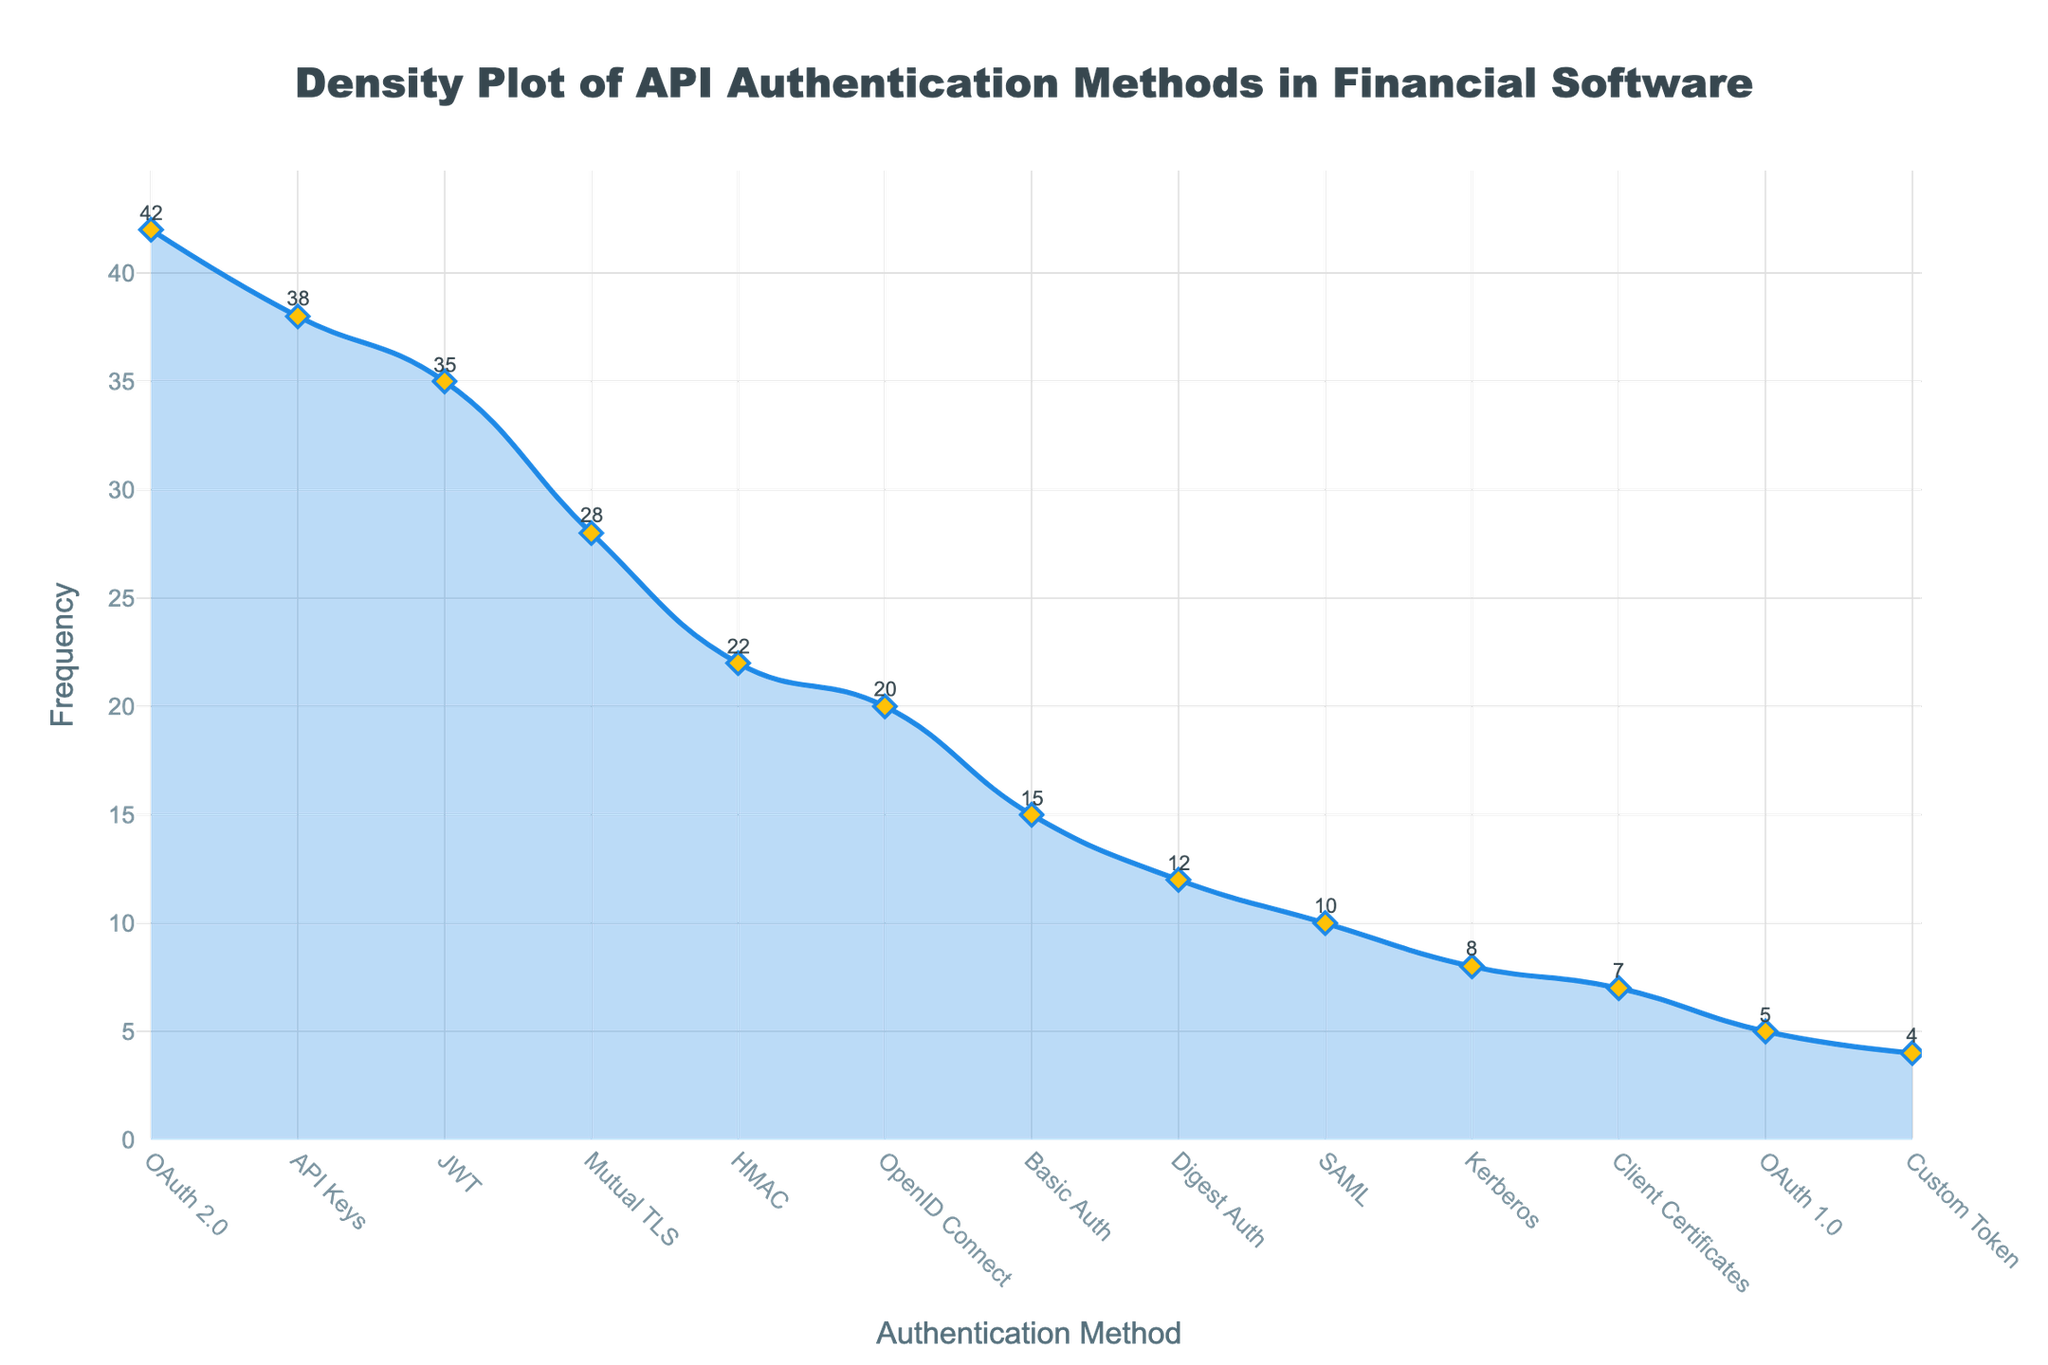What's the title of the plot? The title is displayed at the top of the plot and is formatted in a large, bold text.
Answer: Density Plot of API Authentication Methods in Financial Software Which authentication method has the highest frequency? By looking at the peak of the density plot and the corresponding label on the x-axis, one can see the highest peak corresponds to OAuth 2.0.
Answer: OAuth 2.0 How many authentication methods have a frequency greater than 30? We need to count the number of peaks in the plot that rise above the 30 mark on the y-axis. These correspond to OAuth 2.0, API Keys, and JWT.
Answer: 3 What is the approximate frequency difference between the highest and lowest reported methods? Identify the frequencies of the highest (OAuth 2.0 with 42) and lowest (Custom Token with 4) methods and subtract the latter from the former.
Answer: 38 Which two authentication methods have the closest frequencies, and what are their values? Compare frequency values closer to each other visually. Mutual TLS (28) and HMAC (22) have the closest frequencies with a difference of 6.
Answer: Mutual TLS and HMAC, with frequencies 28 and 22 What can you say about the trend of frequencies regarding API Key usage compared to JWT usage? The trend line for API Keys is slightly higher but close to the JWT trend line, which suggests that both methods have a similar level of use but API Keys are slightly more frequent.
Answer: API Keys are slightly more frequent than JWT Which authentication method shows the least frequency? The lowest point on the density plot corresponds to Custom Token.
Answer: Custom Token If we group the methods into two categories, those above 15 and those below 15, how many methods are in each category? Count the methods in each group. Above 15: OAuth 2.0, API Keys, JWT, Mutual TLS, HMAC, OpenID Connect, Basic Auth (7 methods), Below 15: Digest Auth, SAML, Kerberos, Client Certificates, OAuth 1.0, Custom Token (6 methods).
Answer: Above 15: 7, Below 15: 6 What is the median frequency of the authentication methods? Arrange frequencies (42, 38, 35, 28, 22, 20, 15, 12, 10, 8, 7, 5, 4) in a list and find the middle value.
Answer: 15 